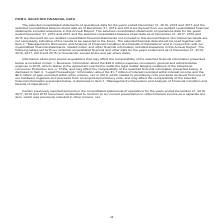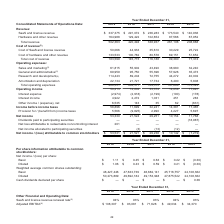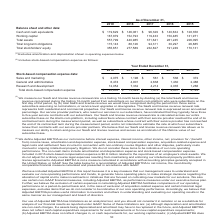According to Alarmcom Holdings's financial document, What was the adjusted EBITDA in 2019? According to the financial document, $108,307 (in thousands). The relevant text states: "ate (3) 94% 93% 93% 94% 93% Adjusted EBITDA (4) $ 108,307 $ 93,081 $ 71,628 $ 49,034 $ 34,370..." Also, What was the SaaS and license revenue renewal rate in 2018? According to the financial document, 93%. The relevant text states: "ata: SaaS and license revenue renewal rate (3) 94% 93% 93% 94% 93% Adjusted EBITDA (4) $ 108,307 $ 93,081 $ 71,628 $ 49,034 $ 34,370..." Also, Which years does the table provide data for adjusted EBITDA for? The document contains multiple relevant values: 2019, 2018, 2017, 2016, 2015. From the document: "Consolidated Statements of Operations Data: 2019 2018 2017 2016 2015 Revenue: SaaS and license revenue $ 337,375 $ 291,072 $ 236,283 $ 173,540 $ 140,9..." Also, How many years did the adjusted EBITDA exceed $50,000 thousand? Counting the relevant items in the document: 2019, 2018, 2017, I find 3 instances. The key data points involved are: 2017, 2018, 2019. Also, can you calculate: What was the change in the SaaS and license revenue renewal rate between 2018 and 2019? Based on the calculation: 94-93, the result is 1 (percentage). This is based on the information: "g Data: SaaS and license revenue renewal rate (3) 94% 93% 93% 94% 93% Adjusted EBITDA (4) $ 108,307 $ 93,081 $ 71,628 $ 49,034 $ 34,370 ta: SaaS and license revenue renewal rate (3) 94% 93% 93% 94% 93..." The key data points involved are: 93, 94. Also, can you calculate: What was the percentage change in adjusted EBITDA between 2018 and 2019? To answer this question, I need to perform calculations using the financial data. The calculation is: (108,307-93,081)/93,081, which equals 16.36 (percentage). This is based on the information: "% 93% 93% 94% 93% Adjusted EBITDA (4) $ 108,307 $ 93,081 $ 71,628 $ 49,034 $ 34,370 ate (3) 94% 93% 93% 94% 93% Adjusted EBITDA (4) $ 108,307 $ 93,081 $ 71,628 $ 49,034 $ 34,370..." The key data points involved are: 108,307, 93,081. 